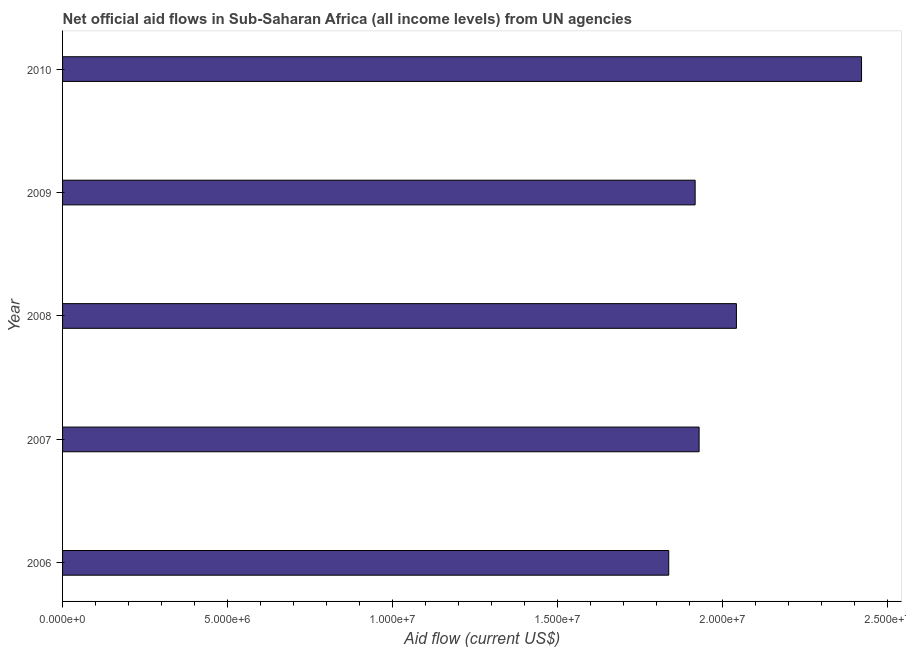Does the graph contain grids?
Give a very brief answer. No. What is the title of the graph?
Your answer should be compact. Net official aid flows in Sub-Saharan Africa (all income levels) from UN agencies. What is the label or title of the Y-axis?
Provide a short and direct response. Year. What is the net official flows from un agencies in 2009?
Offer a terse response. 1.92e+07. Across all years, what is the maximum net official flows from un agencies?
Give a very brief answer. 2.42e+07. Across all years, what is the minimum net official flows from un agencies?
Keep it short and to the point. 1.84e+07. In which year was the net official flows from un agencies minimum?
Offer a very short reply. 2006. What is the sum of the net official flows from un agencies?
Your answer should be very brief. 1.01e+08. What is the difference between the net official flows from un agencies in 2009 and 2010?
Your answer should be compact. -5.04e+06. What is the average net official flows from un agencies per year?
Keep it short and to the point. 2.03e+07. What is the median net official flows from un agencies?
Ensure brevity in your answer.  1.93e+07. What is the ratio of the net official flows from un agencies in 2007 to that in 2009?
Keep it short and to the point. 1.01. Is the net official flows from un agencies in 2009 less than that in 2010?
Ensure brevity in your answer.  Yes. What is the difference between the highest and the second highest net official flows from un agencies?
Offer a terse response. 3.79e+06. Is the sum of the net official flows from un agencies in 2008 and 2009 greater than the maximum net official flows from un agencies across all years?
Make the answer very short. Yes. What is the difference between the highest and the lowest net official flows from un agencies?
Provide a succinct answer. 5.84e+06. Are the values on the major ticks of X-axis written in scientific E-notation?
Ensure brevity in your answer.  Yes. What is the Aid flow (current US$) of 2006?
Make the answer very short. 1.84e+07. What is the Aid flow (current US$) of 2007?
Provide a succinct answer. 1.93e+07. What is the Aid flow (current US$) in 2008?
Provide a succinct answer. 2.04e+07. What is the Aid flow (current US$) of 2009?
Your response must be concise. 1.92e+07. What is the Aid flow (current US$) in 2010?
Your response must be concise. 2.42e+07. What is the difference between the Aid flow (current US$) in 2006 and 2007?
Keep it short and to the point. -9.20e+05. What is the difference between the Aid flow (current US$) in 2006 and 2008?
Offer a terse response. -2.05e+06. What is the difference between the Aid flow (current US$) in 2006 and 2009?
Your answer should be compact. -8.00e+05. What is the difference between the Aid flow (current US$) in 2006 and 2010?
Give a very brief answer. -5.84e+06. What is the difference between the Aid flow (current US$) in 2007 and 2008?
Keep it short and to the point. -1.13e+06. What is the difference between the Aid flow (current US$) in 2007 and 2009?
Keep it short and to the point. 1.20e+05. What is the difference between the Aid flow (current US$) in 2007 and 2010?
Offer a very short reply. -4.92e+06. What is the difference between the Aid flow (current US$) in 2008 and 2009?
Ensure brevity in your answer.  1.25e+06. What is the difference between the Aid flow (current US$) in 2008 and 2010?
Your answer should be compact. -3.79e+06. What is the difference between the Aid flow (current US$) in 2009 and 2010?
Your response must be concise. -5.04e+06. What is the ratio of the Aid flow (current US$) in 2006 to that in 2009?
Offer a terse response. 0.96. What is the ratio of the Aid flow (current US$) in 2006 to that in 2010?
Ensure brevity in your answer.  0.76. What is the ratio of the Aid flow (current US$) in 2007 to that in 2008?
Offer a terse response. 0.94. What is the ratio of the Aid flow (current US$) in 2007 to that in 2010?
Your answer should be compact. 0.8. What is the ratio of the Aid flow (current US$) in 2008 to that in 2009?
Offer a very short reply. 1.06. What is the ratio of the Aid flow (current US$) in 2008 to that in 2010?
Offer a very short reply. 0.84. What is the ratio of the Aid flow (current US$) in 2009 to that in 2010?
Give a very brief answer. 0.79. 